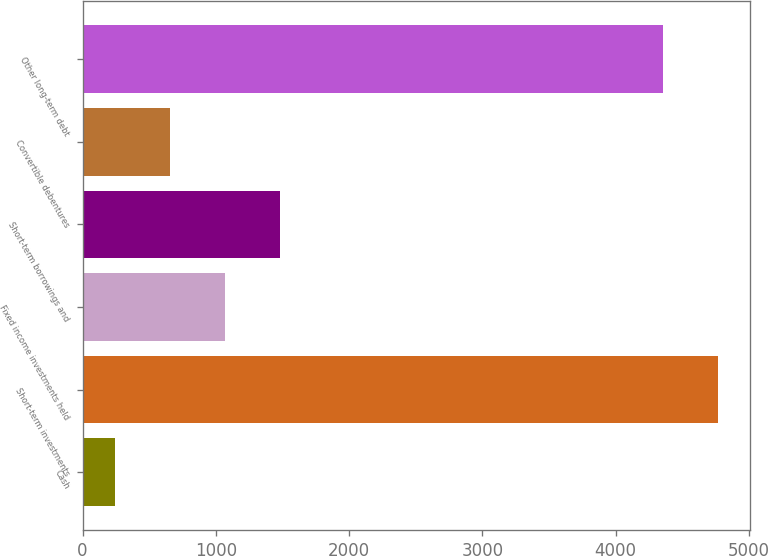<chart> <loc_0><loc_0><loc_500><loc_500><bar_chart><fcel>Cash<fcel>Short-term investments<fcel>Fixed income investments held<fcel>Short-term borrowings and<fcel>Convertible debentures<fcel>Other long-term debt<nl><fcel>243<fcel>4768<fcel>1069<fcel>1482<fcel>656<fcel>4355<nl></chart> 